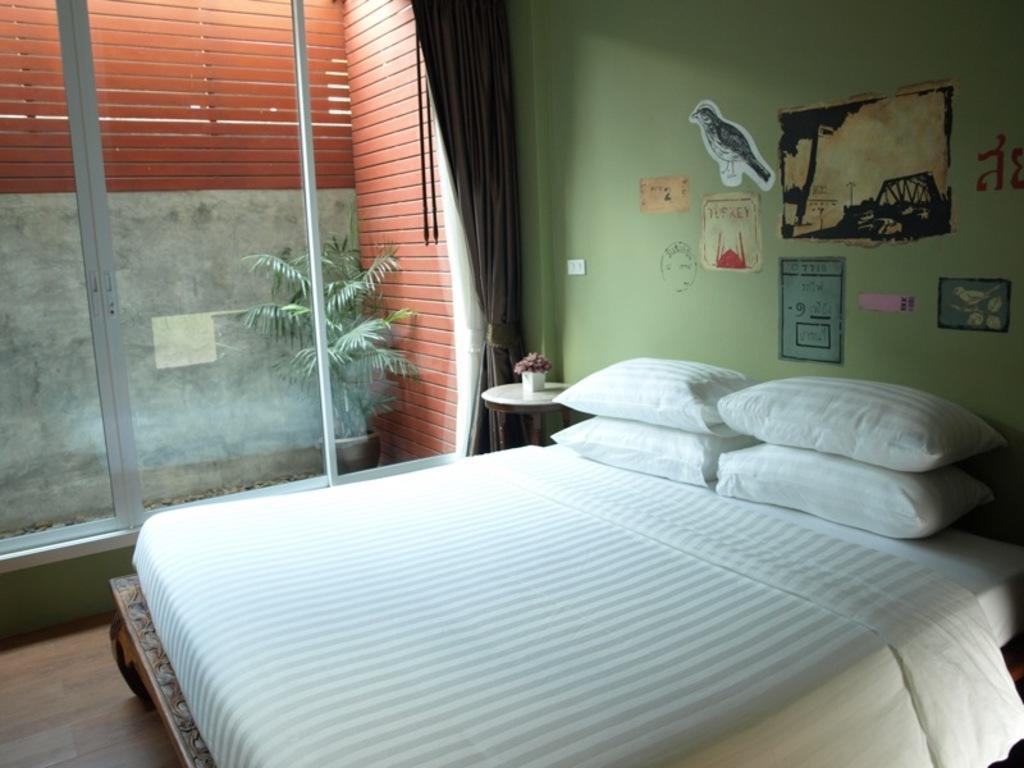Could you give a brief overview of what you see in this image? In this image there is a bed with pillows on it, beside that there is a table with a flower pot on top of it and there are paintings on the wall. In the background there is a glass door, in front of that there is a plant pot on the balcony. 